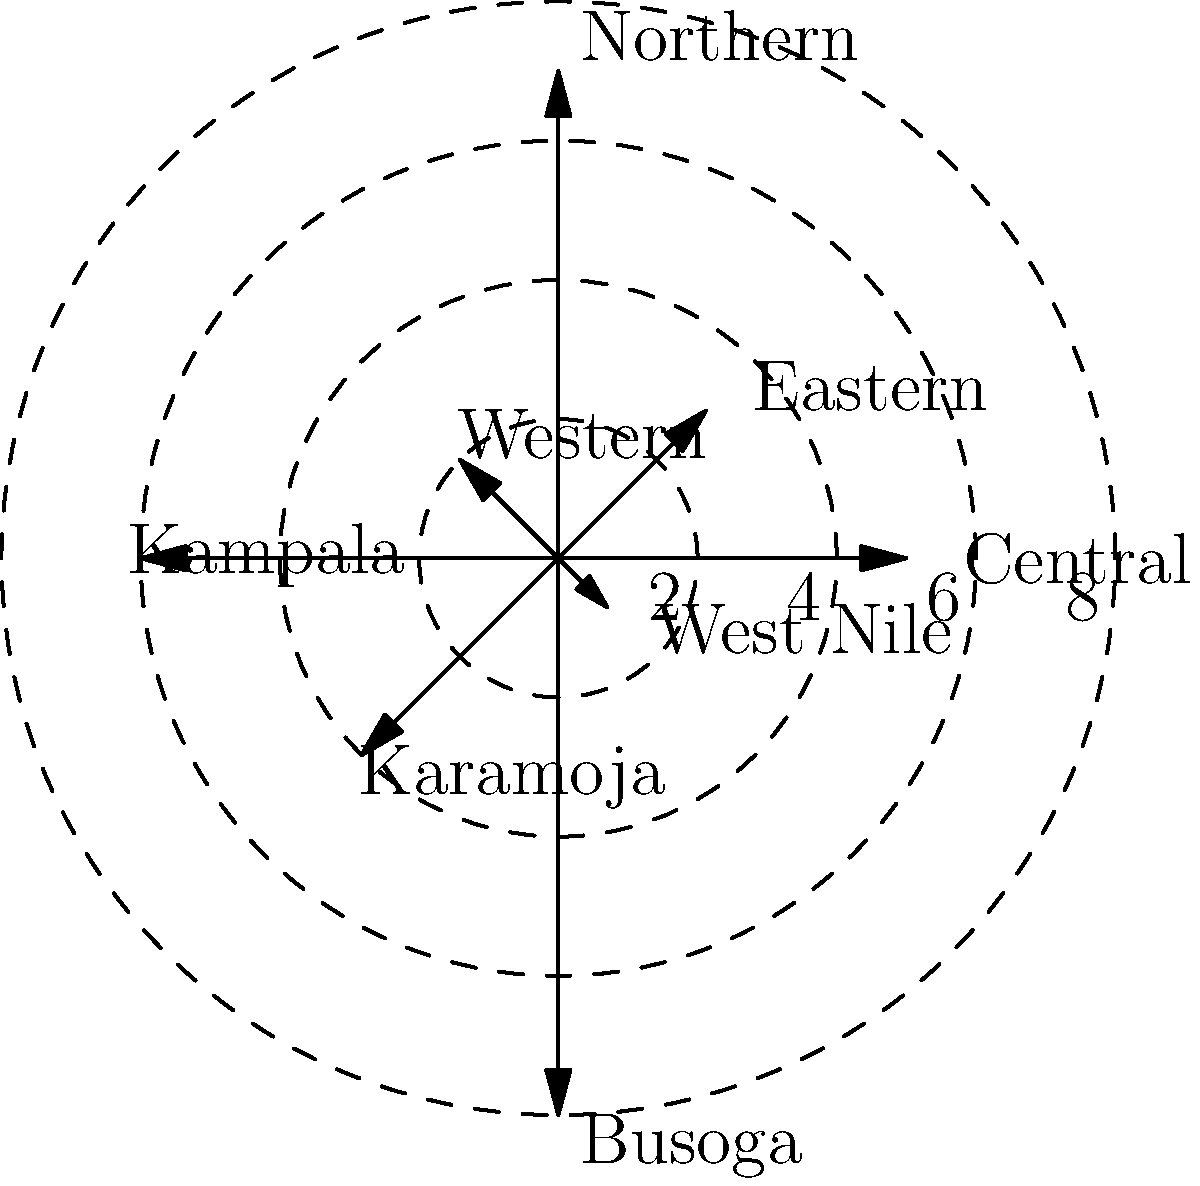The polar coordinate plot above shows the distribution of medical facilities across different regions of Uganda. Each line represents a region, with the angle indicating the geographic direction and the length representing the number of medical facilities per 100,000 people. Which region has the highest density of medical facilities, and what is its approximate value? To determine the region with the highest density of medical facilities, we need to identify the longest line in the polar plot, as the length of each line represents the number of medical facilities per 100,000 people in that region.

Steps to solve:
1. Examine each line in the plot and compare their lengths.
2. The longest line extends to the outermost circle, which represents 8 facilities per 100,000 people.
3. Identify the region associated with this longest line.

Looking at the plot:
- Central: approximately 5
- Eastern: approximately 3
- Northern: approximately 7
- Western: approximately 2
- Kampala: approximately 6
- Karamoja: approximately 4
- Busoga: approximately 8
- West Nile: approximately 1

The longest line corresponds to the Busoga region, reaching the outermost circle at 8.

Therefore, Busoga has the highest density of medical facilities with approximately 8 facilities per 100,000 people.
Answer: Busoga, 8 per 100,000 